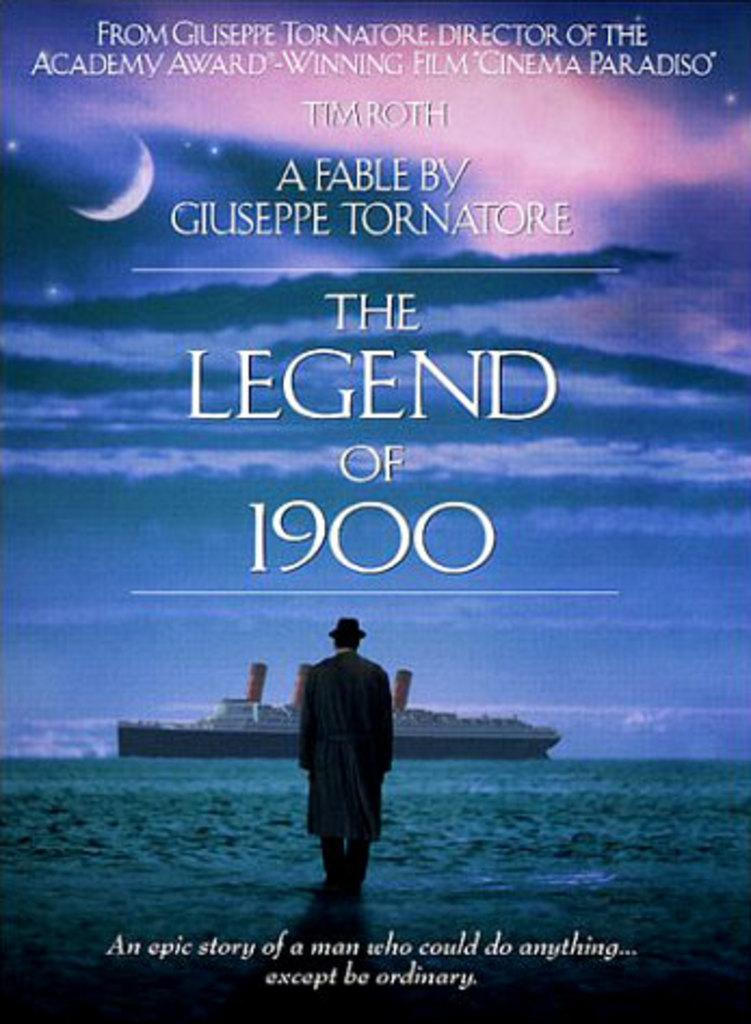<image>
Provide a brief description of the given image. a movie poster called the legend of 1900 